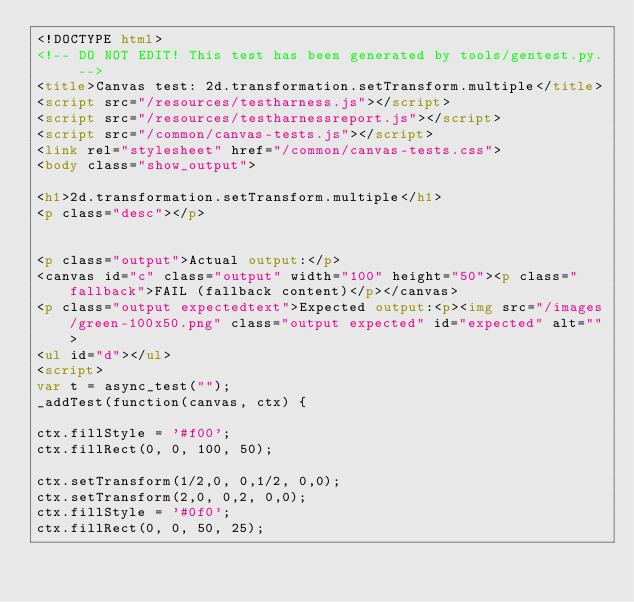Convert code to text. <code><loc_0><loc_0><loc_500><loc_500><_HTML_><!DOCTYPE html>
<!-- DO NOT EDIT! This test has been generated by tools/gentest.py. -->
<title>Canvas test: 2d.transformation.setTransform.multiple</title>
<script src="/resources/testharness.js"></script>
<script src="/resources/testharnessreport.js"></script>
<script src="/common/canvas-tests.js"></script>
<link rel="stylesheet" href="/common/canvas-tests.css">
<body class="show_output">

<h1>2d.transformation.setTransform.multiple</h1>
<p class="desc"></p>


<p class="output">Actual output:</p>
<canvas id="c" class="output" width="100" height="50"><p class="fallback">FAIL (fallback content)</p></canvas>
<p class="output expectedtext">Expected output:<p><img src="/images/green-100x50.png" class="output expected" id="expected" alt="">
<ul id="d"></ul>
<script>
var t = async_test("");
_addTest(function(canvas, ctx) {

ctx.fillStyle = '#f00';
ctx.fillRect(0, 0, 100, 50);

ctx.setTransform(1/2,0, 0,1/2, 0,0);
ctx.setTransform(2,0, 0,2, 0,0);
ctx.fillStyle = '#0f0';
ctx.fillRect(0, 0, 50, 25);</code> 